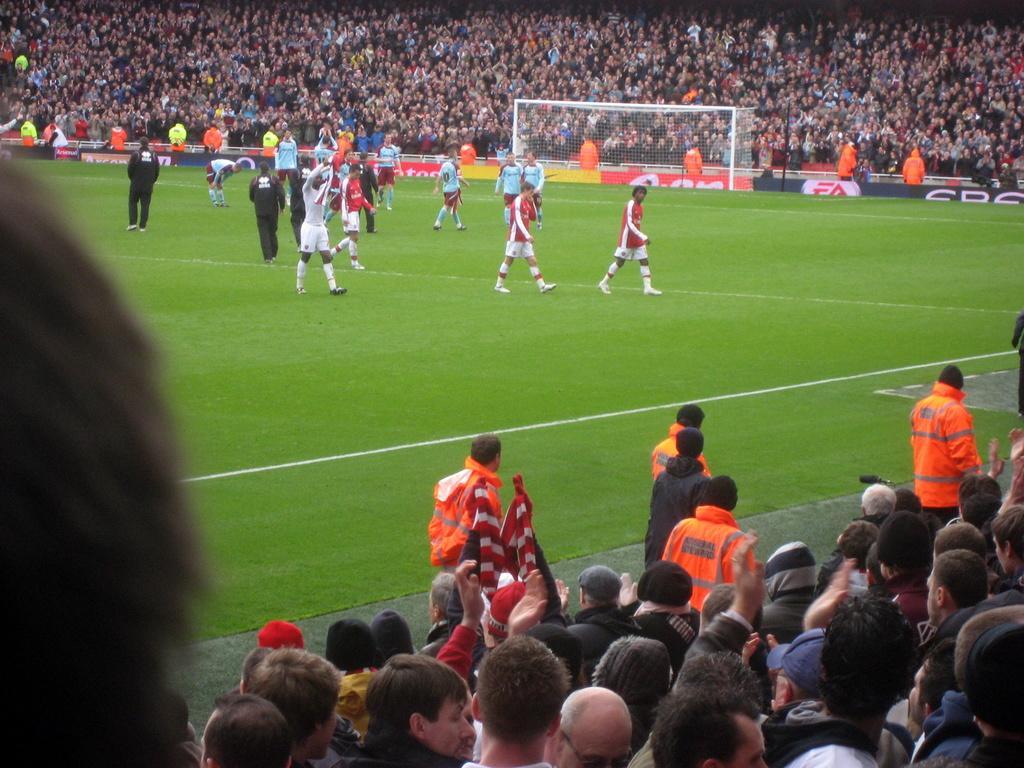How would you summarize this image in a sentence or two? Here we can see group of people on the ground. There are hoardings and a mesh. In the background we can see crowd. 